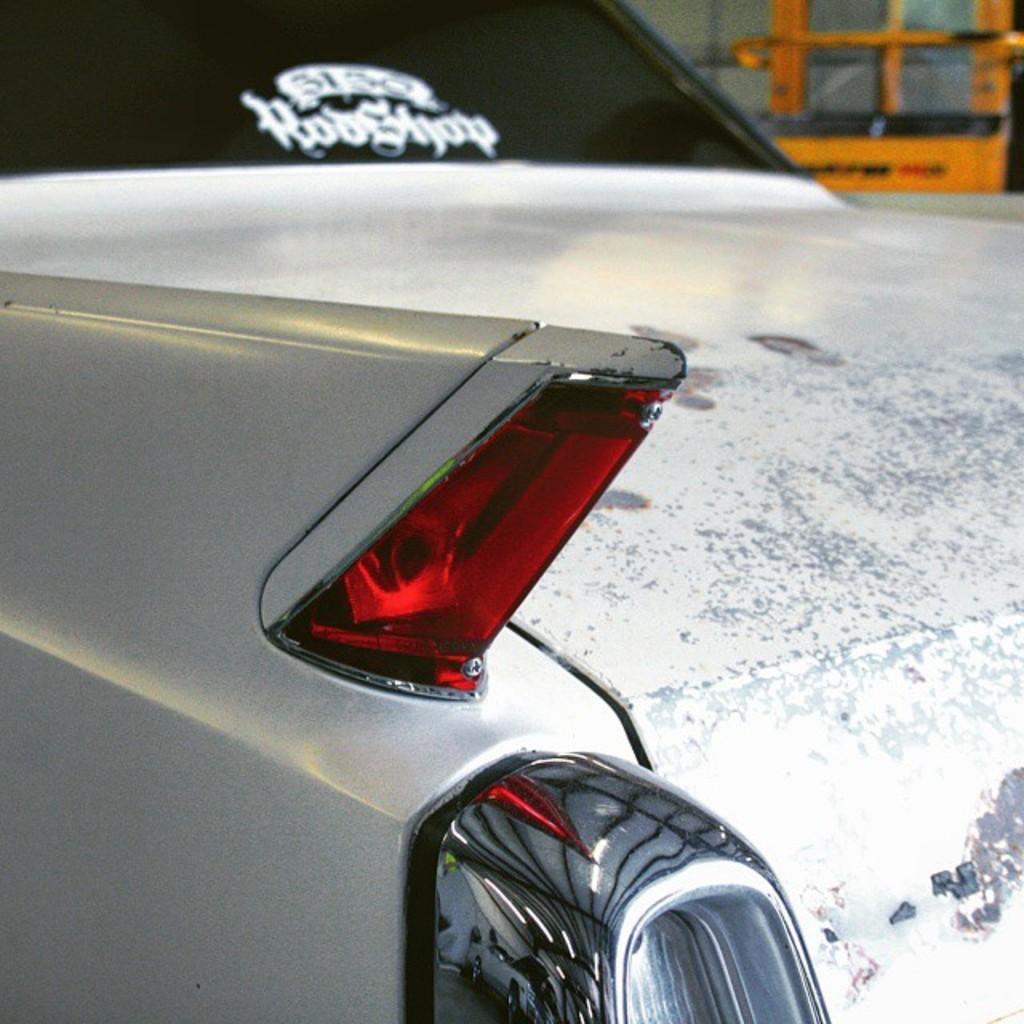Could you give a brief overview of what you see in this image? In front of the image there is a car. Behind the car there is some object. 